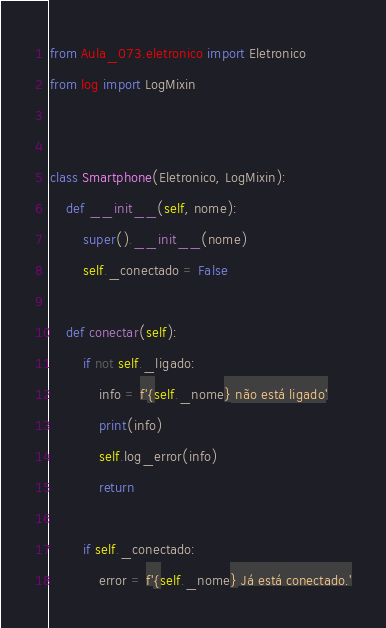<code> <loc_0><loc_0><loc_500><loc_500><_Python_>from Aula_073.eletronico import Eletronico
from log import LogMixin


class Smartphone(Eletronico, LogMixin):
    def __init__(self, nome):
        super().__init__(nome)
        self._conectado = False

    def conectar(self):
        if not self._ligado:
            info = f'{self._nome} não está ligado'
            print(info)
            self.log_error(info)
            return

        if self._conectado:
            error = f'{self._nome} Já está conectado.'</code> 